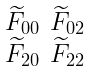<formula> <loc_0><loc_0><loc_500><loc_500>\begin{smallmatrix} \widetilde { F } _ { 0 0 } & \widetilde { F } _ { 0 2 } \\ \widetilde { F } _ { 2 0 } & \widetilde { F } _ { 2 2 } \end{smallmatrix}</formula> 